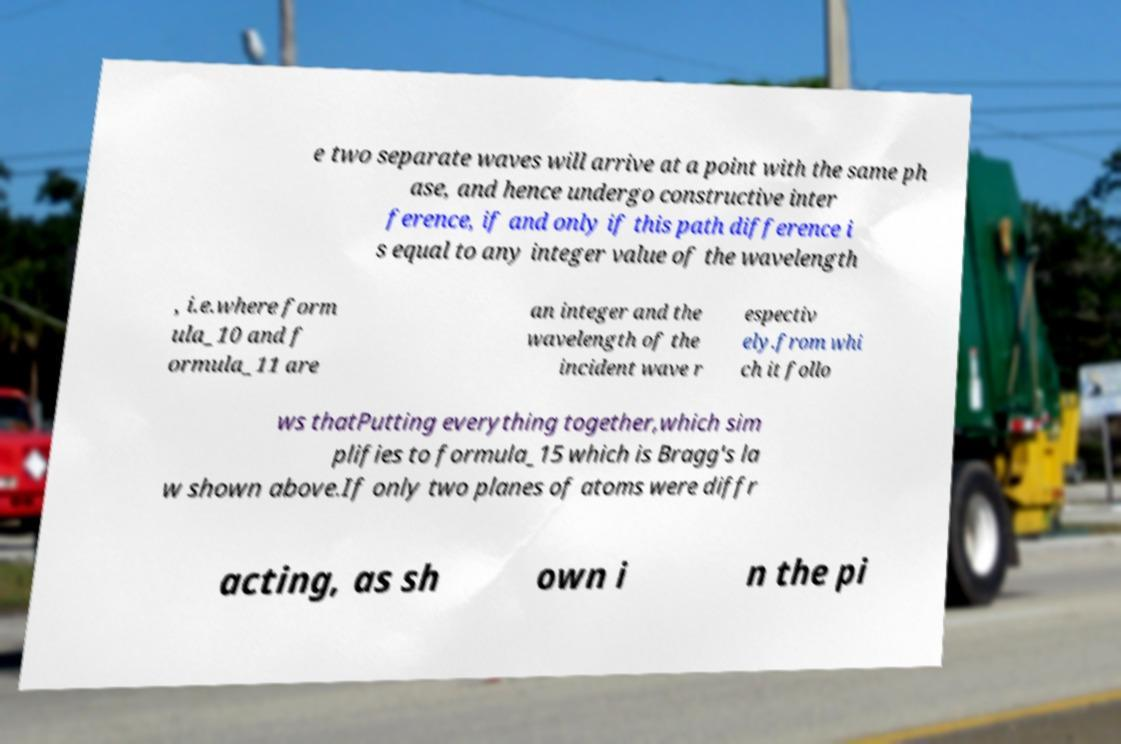What messages or text are displayed in this image? I need them in a readable, typed format. e two separate waves will arrive at a point with the same ph ase, and hence undergo constructive inter ference, if and only if this path difference i s equal to any integer value of the wavelength , i.e.where form ula_10 and f ormula_11 are an integer and the wavelength of the incident wave r espectiv ely.from whi ch it follo ws thatPutting everything together,which sim plifies to formula_15 which is Bragg's la w shown above.If only two planes of atoms were diffr acting, as sh own i n the pi 